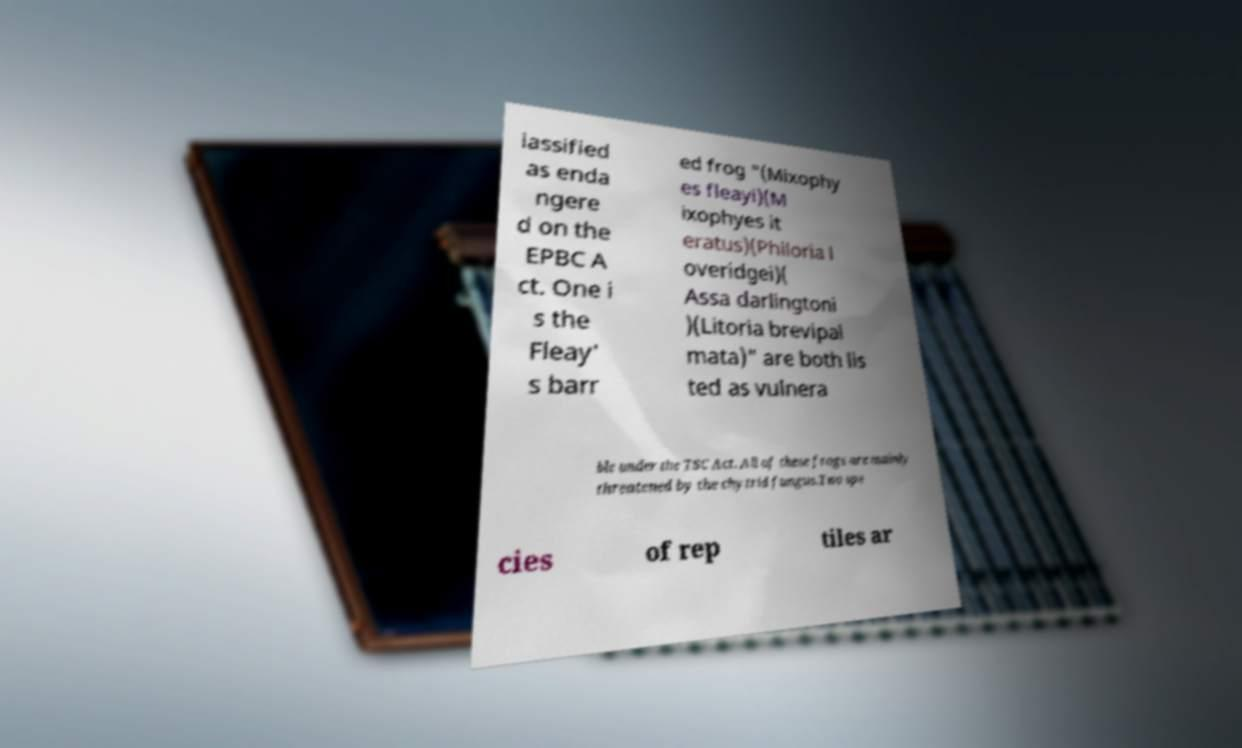Please identify and transcribe the text found in this image. lassified as enda ngere d on the EPBC A ct. One i s the Fleay' s barr ed frog "(Mixophy es fleayi)(M ixophyes it eratus)(Philoria l overidgei)( Assa darlingtoni )(Litoria brevipal mata)" are both lis ted as vulnera ble under the TSC Act. All of these frogs are mainly threatened by the chytrid fungus.Two spe cies of rep tiles ar 